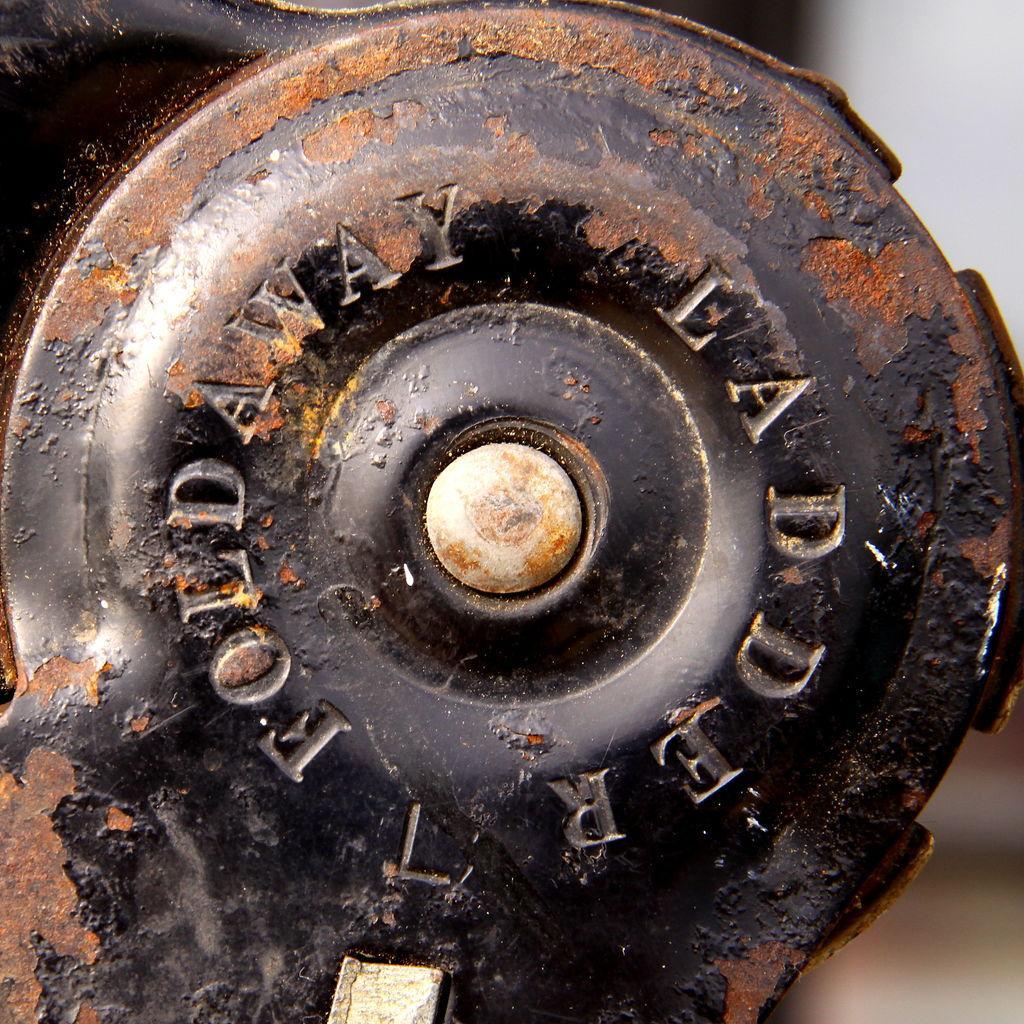In one or two sentences, can you explain what this image depicts? In this picture we can see a rusted iron object. Behind the object there is a blurred background. 